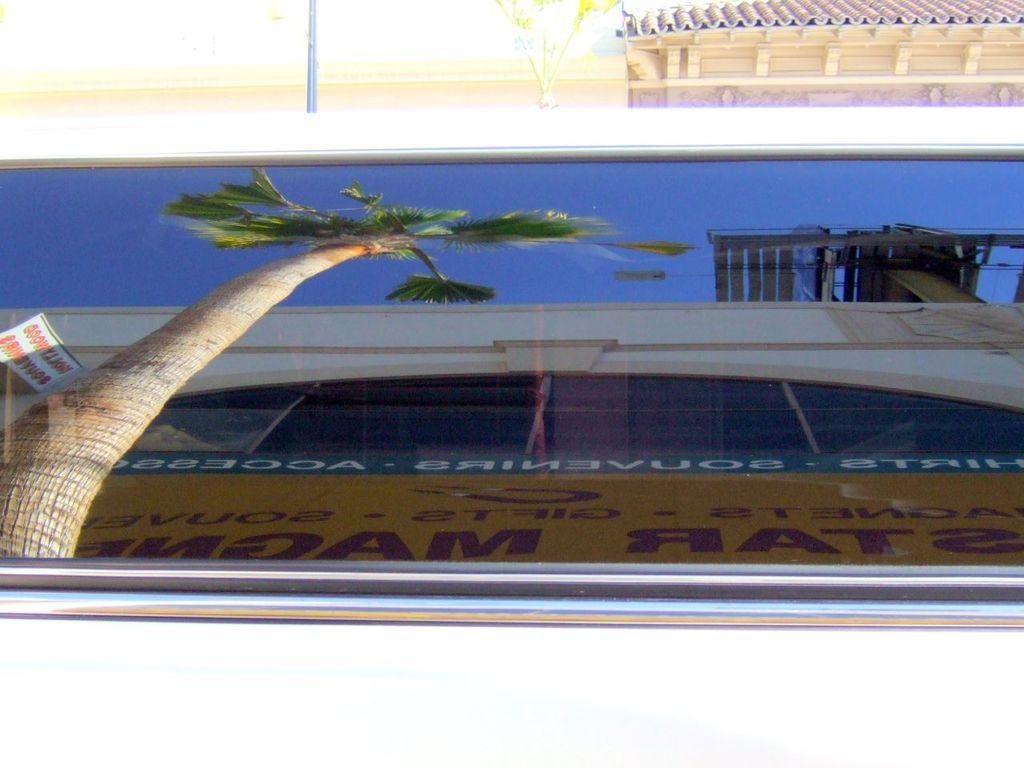What object is visible in the image that can hold a liquid? There is a glass in the image. What does the glass reflect in the image? The glass reflects a tree, a building, a board, and the sky in the image. What can be seen in the background of the image? There is a wall, a roof top, and a plant in the background of the image. What type of crown is placed on the plant in the image? There is no crown present in the image; it only features a glass and its reflections, as well as the background elements. 